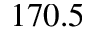Convert formula to latex. <formula><loc_0><loc_0><loc_500><loc_500>1 7 0 . 5</formula> 